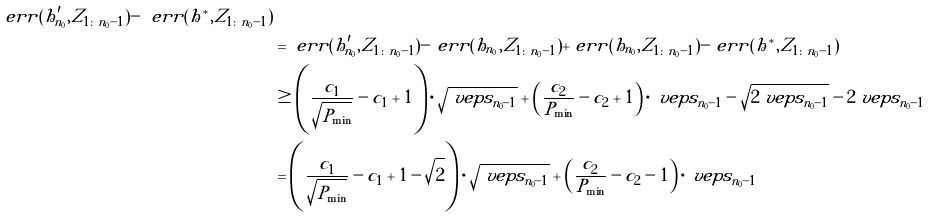Convert formula to latex. <formula><loc_0><loc_0><loc_500><loc_500>{ \ e r r ( h _ { n _ { 0 } } ^ { \prime } , Z _ { 1 \colon n _ { 0 } - 1 } ) - \ e r r ( h ^ { * } , Z _ { 1 \colon n _ { 0 } - 1 } ) } \\ & = \ e r r ( h _ { n _ { 0 } } ^ { \prime } , Z _ { 1 \colon n _ { 0 } - 1 } ) - \ e r r ( h _ { n _ { 0 } } , Z _ { 1 \colon n _ { 0 } - 1 } ) + \ e r r ( h _ { n _ { 0 } } , Z _ { 1 \colon n _ { 0 } - 1 } ) - \ e r r ( h ^ { * } , Z _ { 1 \colon n _ { 0 } - 1 } ) \\ & \geq \left ( \frac { c _ { 1 } } { \sqrt { P _ { \min } } } - c _ { 1 } + 1 \right ) \cdot \sqrt { \ v e p s _ { n _ { 0 } - 1 } } + \left ( \frac { c _ { 2 } } { P _ { \min } } - c _ { 2 } + 1 \right ) \cdot \ v e p s _ { n _ { 0 } - 1 } - \sqrt { 2 \ v e p s _ { n _ { 0 } - 1 } } - 2 \ v e p s _ { n _ { 0 } - 1 } \\ & = \left ( \frac { c _ { 1 } } { \sqrt { P _ { \min } } } - c _ { 1 } + 1 - \sqrt { 2 } \right ) \cdot \sqrt { \ v e p s _ { n _ { 0 } - 1 } } + \left ( \frac { c _ { 2 } } { P _ { \min } } - c _ { 2 } - 1 \right ) \cdot \ v e p s _ { n _ { 0 } - 1 }</formula> 